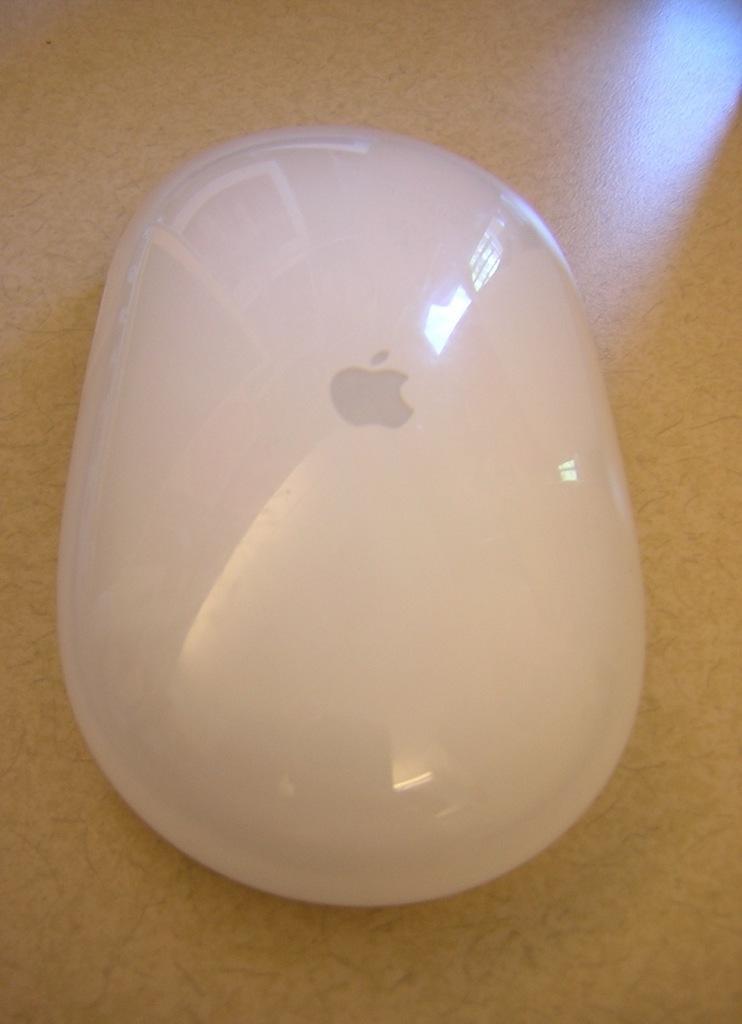In one or two sentences, can you explain what this image depicts? This image consists of a mouse in white color is kept on the table. The table is made up of wood. 